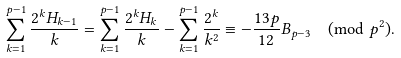Convert formula to latex. <formula><loc_0><loc_0><loc_500><loc_500>\sum _ { k = 1 } ^ { p - 1 } \frac { 2 ^ { k } H _ { k - 1 } } { k } = \sum _ { k = 1 } ^ { p - 1 } \frac { 2 ^ { k } H _ { k } } { k } - \sum _ { k = 1 } ^ { p - 1 } \frac { 2 ^ { k } } { k ^ { 2 } } \equiv - \frac { 1 3 p } { 1 2 } B _ { p - 3 } \pmod { p ^ { 2 } } .</formula> 